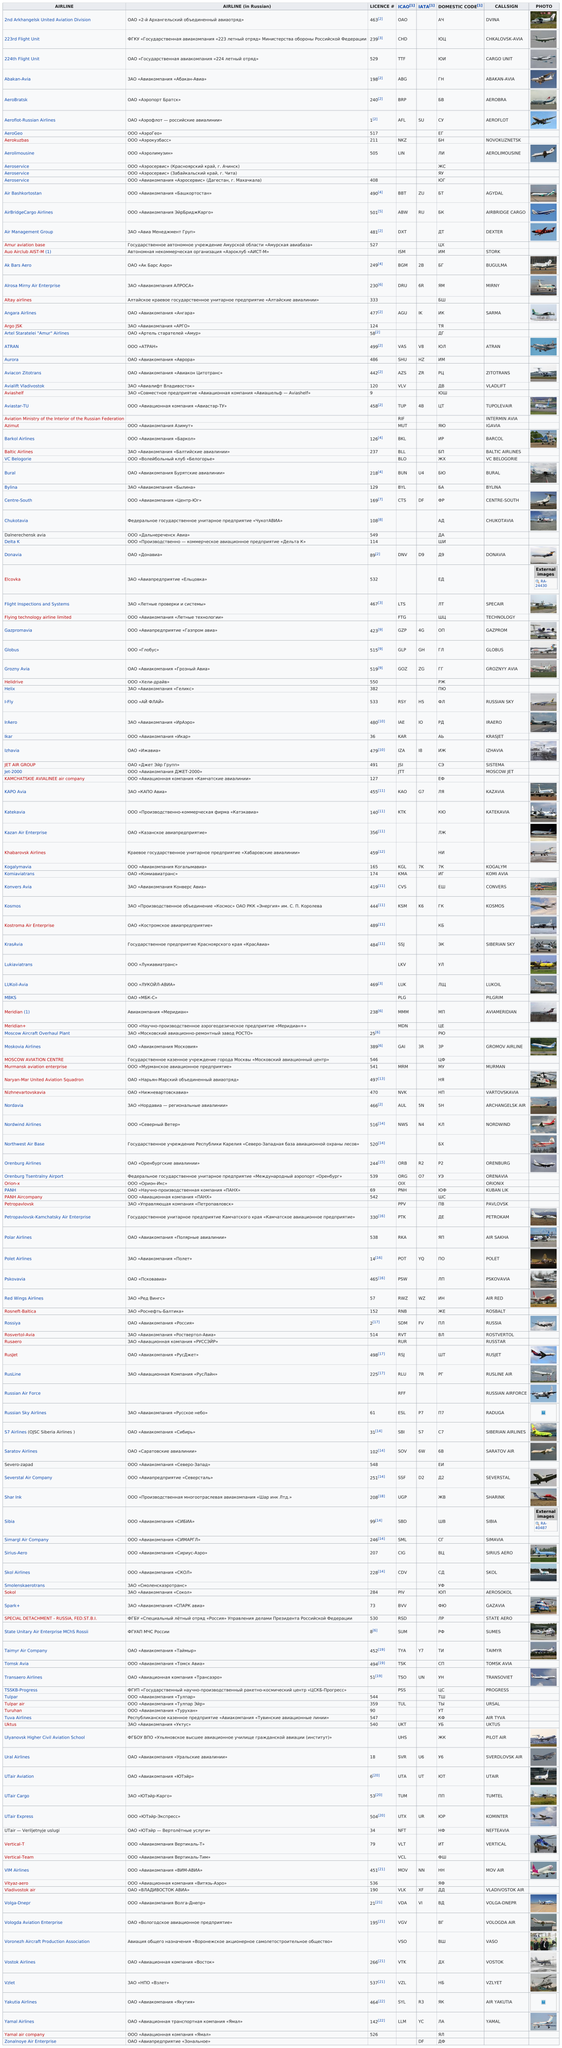Mention a couple of crucial points in this snapshot. After license number 198, the number listed is 240. Polar Airlines is the airline that bears the call sign Air Sakha. Helidrive is an airline that holds the highest license number among all airlines. KrasAvia is the only airline that uses the callsign "siberian sky. It is known that Donavia or Rusjet airline has a license number of 498, and it is referred to as RusJet. 